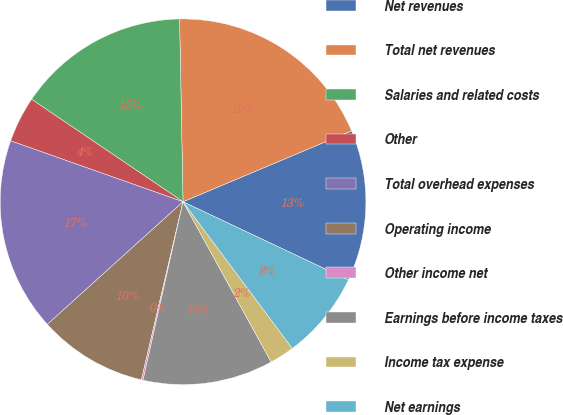Convert chart. <chart><loc_0><loc_0><loc_500><loc_500><pie_chart><fcel>Net revenues<fcel>Total net revenues<fcel>Salaries and related costs<fcel>Other<fcel>Total overhead expenses<fcel>Operating income<fcel>Other income net<fcel>Earnings before income taxes<fcel>Income tax expense<fcel>Net earnings<nl><fcel>13.37%<fcel>18.96%<fcel>15.23%<fcel>4.06%<fcel>17.1%<fcel>9.65%<fcel>0.15%<fcel>11.51%<fcel>2.19%<fcel>7.78%<nl></chart> 